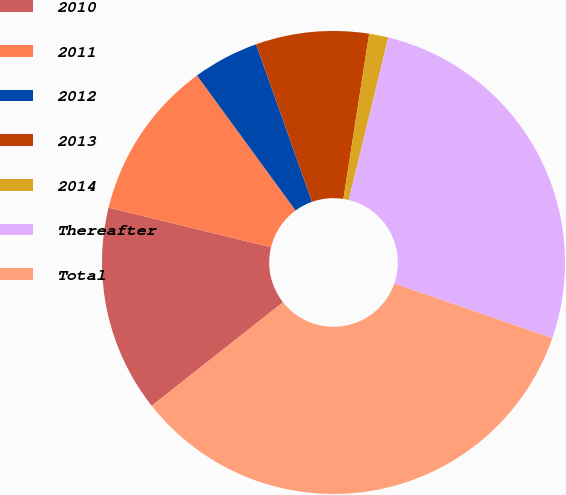Convert chart to OTSL. <chart><loc_0><loc_0><loc_500><loc_500><pie_chart><fcel>2010<fcel>2011<fcel>2012<fcel>2013<fcel>2014<fcel>Thereafter<fcel>Total<nl><fcel>14.43%<fcel>11.16%<fcel>4.61%<fcel>7.89%<fcel>1.34%<fcel>26.5%<fcel>34.07%<nl></chart> 